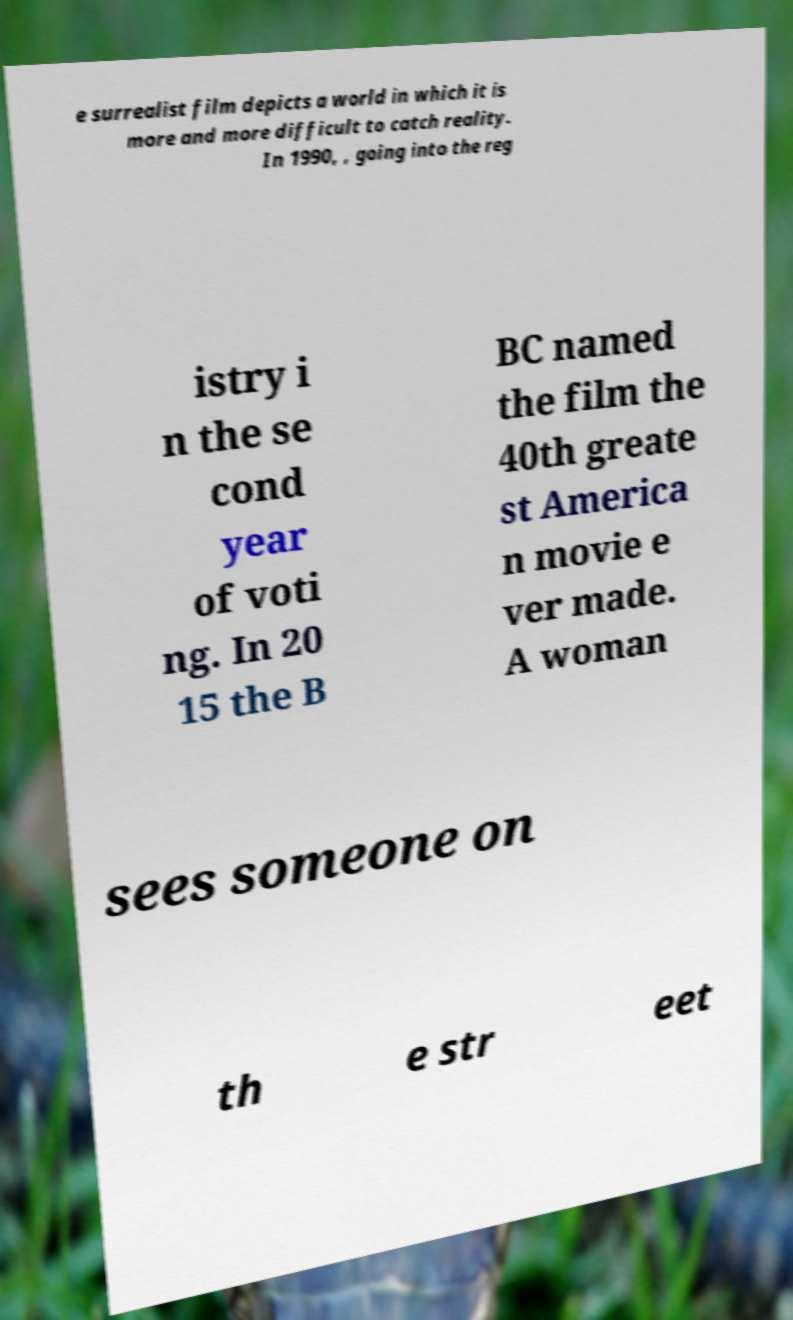Could you extract and type out the text from this image? e surrealist film depicts a world in which it is more and more difficult to catch reality. In 1990, , going into the reg istry i n the se cond year of voti ng. In 20 15 the B BC named the film the 40th greate st America n movie e ver made. A woman sees someone on th e str eet 